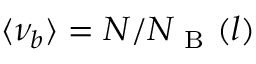Convert formula to latex. <formula><loc_0><loc_0><loc_500><loc_500>\langle \nu _ { b } \rangle = N / N _ { B } ( l )</formula> 